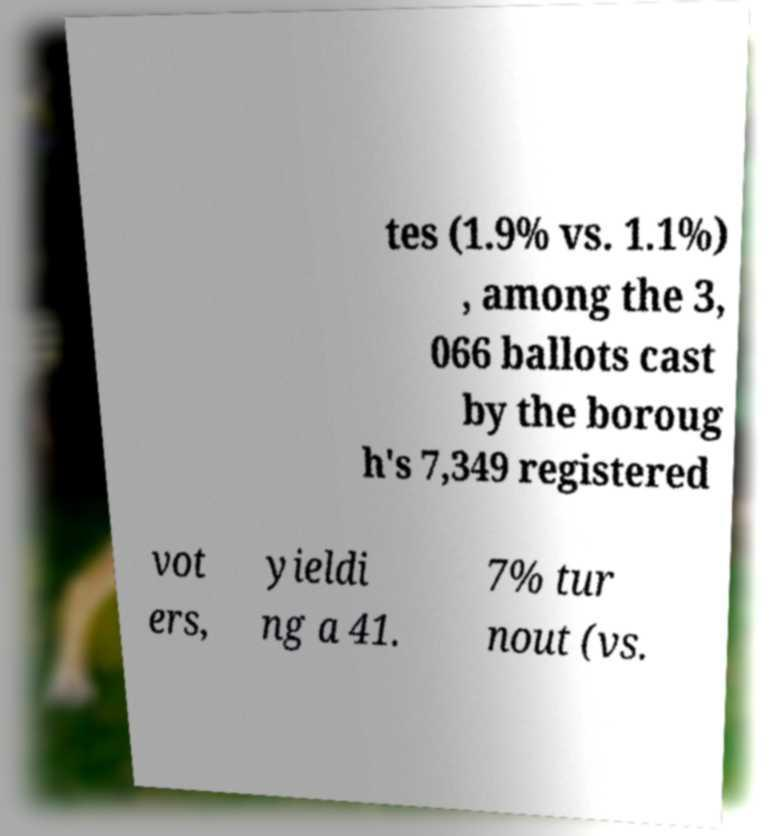Please identify and transcribe the text found in this image. tes (1.9% vs. 1.1%) , among the 3, 066 ballots cast by the boroug h's 7,349 registered vot ers, yieldi ng a 41. 7% tur nout (vs. 